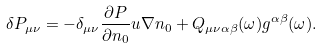<formula> <loc_0><loc_0><loc_500><loc_500>\delta P _ { \mu \nu } = - \delta _ { \mu \nu } \frac { \partial P } { \partial n _ { 0 } } { u } \nabla n _ { 0 } + Q _ { \mu \nu \alpha \beta } ( \omega ) g ^ { \alpha \beta } ( \omega ) .</formula> 